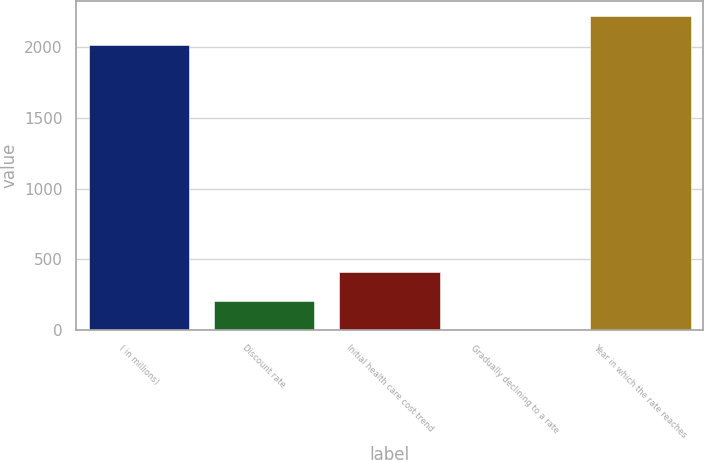<chart> <loc_0><loc_0><loc_500><loc_500><bar_chart><fcel>( in millions)<fcel>Discount rate<fcel>Initial health care cost trend<fcel>Gradually declining to a rate<fcel>Year in which the rate reaches<nl><fcel>2014<fcel>206.7<fcel>408.4<fcel>5<fcel>2215.7<nl></chart> 